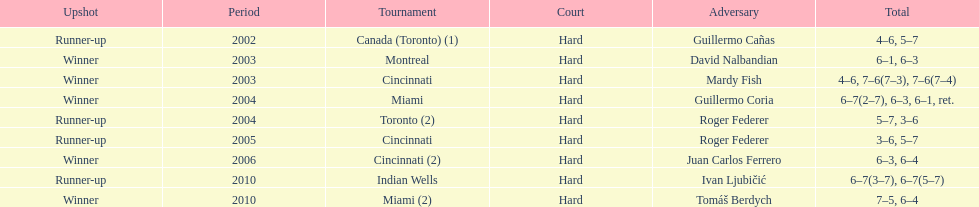What is the maximum number of successive victories he has achieved? 3. 